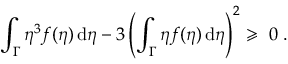<formula> <loc_0><loc_0><loc_500><loc_500>\int _ { \Gamma } \eta ^ { 3 } f ( \eta ) \, d \eta - 3 \left ( \int _ { \Gamma } \eta f ( \eta ) \, d \eta \right ) ^ { 2 } \geqslant \ 0 \, .</formula> 